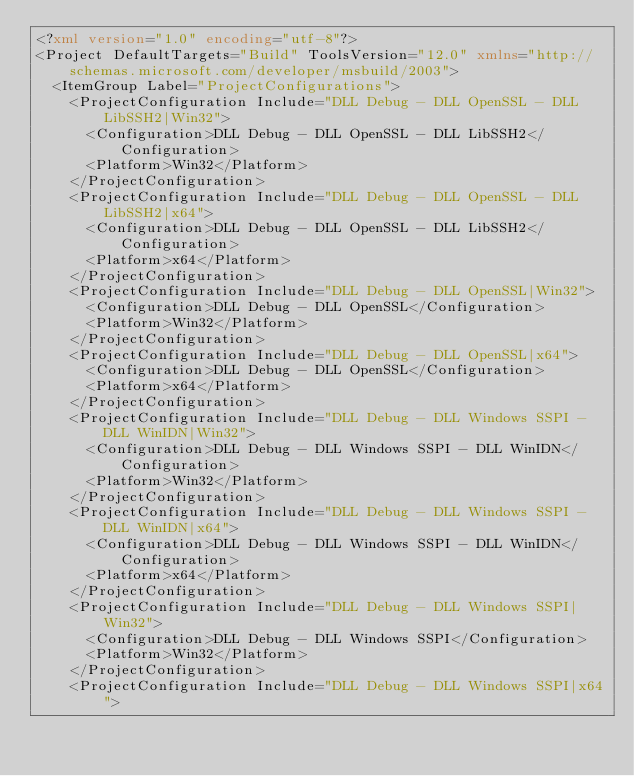Convert code to text. <code><loc_0><loc_0><loc_500><loc_500><_XML_><?xml version="1.0" encoding="utf-8"?>
<Project DefaultTargets="Build" ToolsVersion="12.0" xmlns="http://schemas.microsoft.com/developer/msbuild/2003">
  <ItemGroup Label="ProjectConfigurations">
    <ProjectConfiguration Include="DLL Debug - DLL OpenSSL - DLL LibSSH2|Win32">
      <Configuration>DLL Debug - DLL OpenSSL - DLL LibSSH2</Configuration>
      <Platform>Win32</Platform>
    </ProjectConfiguration>
    <ProjectConfiguration Include="DLL Debug - DLL OpenSSL - DLL LibSSH2|x64">
      <Configuration>DLL Debug - DLL OpenSSL - DLL LibSSH2</Configuration>
      <Platform>x64</Platform>
    </ProjectConfiguration>
    <ProjectConfiguration Include="DLL Debug - DLL OpenSSL|Win32">
      <Configuration>DLL Debug - DLL OpenSSL</Configuration>
      <Platform>Win32</Platform>
    </ProjectConfiguration>
    <ProjectConfiguration Include="DLL Debug - DLL OpenSSL|x64">
      <Configuration>DLL Debug - DLL OpenSSL</Configuration>
      <Platform>x64</Platform>
    </ProjectConfiguration>
    <ProjectConfiguration Include="DLL Debug - DLL Windows SSPI - DLL WinIDN|Win32">
      <Configuration>DLL Debug - DLL Windows SSPI - DLL WinIDN</Configuration>
      <Platform>Win32</Platform>
    </ProjectConfiguration>
    <ProjectConfiguration Include="DLL Debug - DLL Windows SSPI - DLL WinIDN|x64">
      <Configuration>DLL Debug - DLL Windows SSPI - DLL WinIDN</Configuration>
      <Platform>x64</Platform>
    </ProjectConfiguration>
    <ProjectConfiguration Include="DLL Debug - DLL Windows SSPI|Win32">
      <Configuration>DLL Debug - DLL Windows SSPI</Configuration>
      <Platform>Win32</Platform>
    </ProjectConfiguration>
    <ProjectConfiguration Include="DLL Debug - DLL Windows SSPI|x64"></code> 